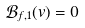<formula> <loc_0><loc_0><loc_500><loc_500>\mathcal { B } _ { f , 1 } ( v ) = 0</formula> 